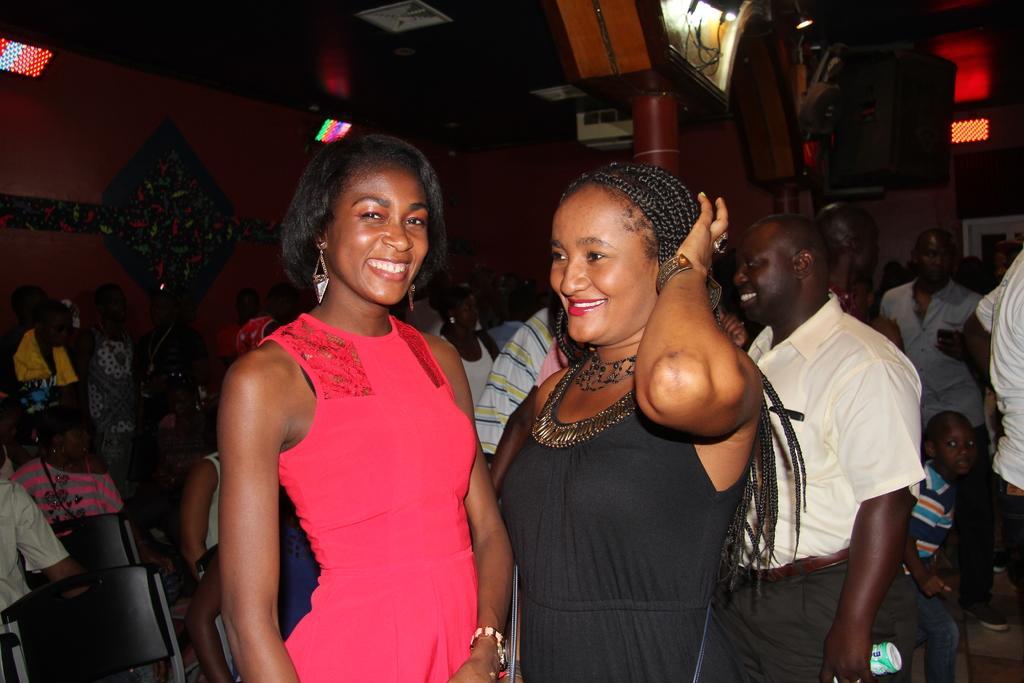In one or two sentences, can you explain what this image depicts? In this image we can see some people are standing on the floor and some are sitting on the chairs. In the background there are electric lights, speakers, projectors and toys. 